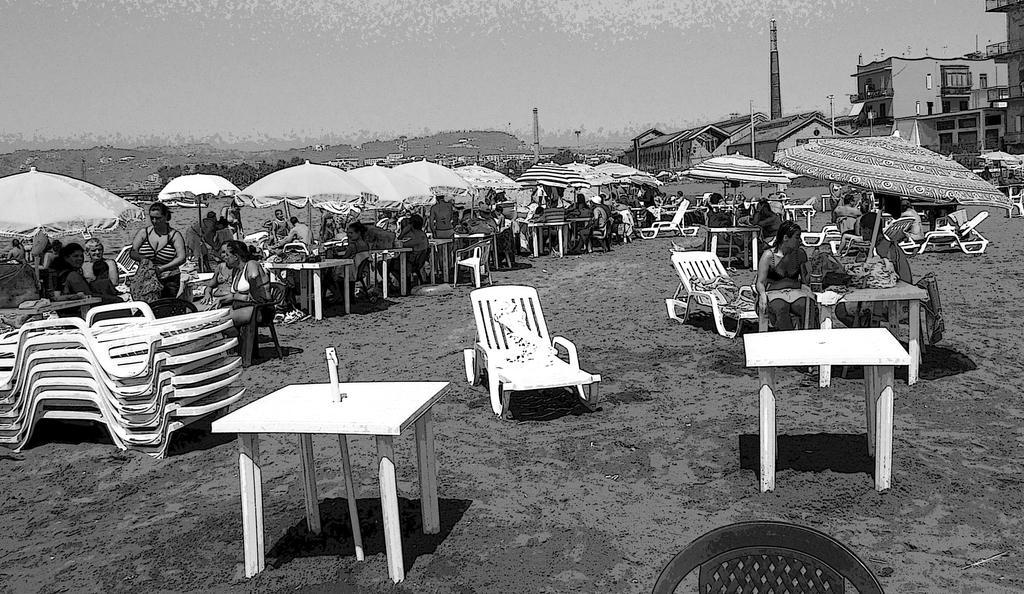How would you summarize this image in a sentence or two? In this image on the left, there is a woman, she is standing and there are many people, tables, umbrellas, trees and land. In the middle there is a table and chair. On the right there are some people, umbrellas, tables, chairs, clothes, buildings and sky. 